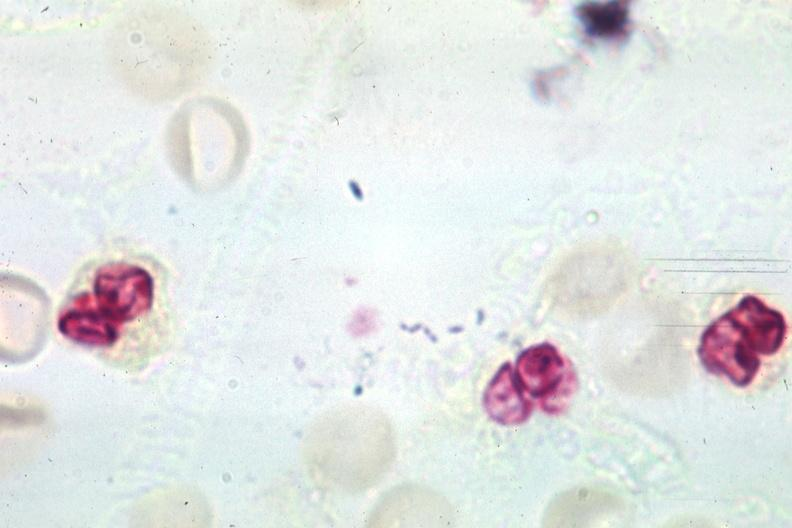does this image show gram organisms well shown?
Answer the question using a single word or phrase. Yes 